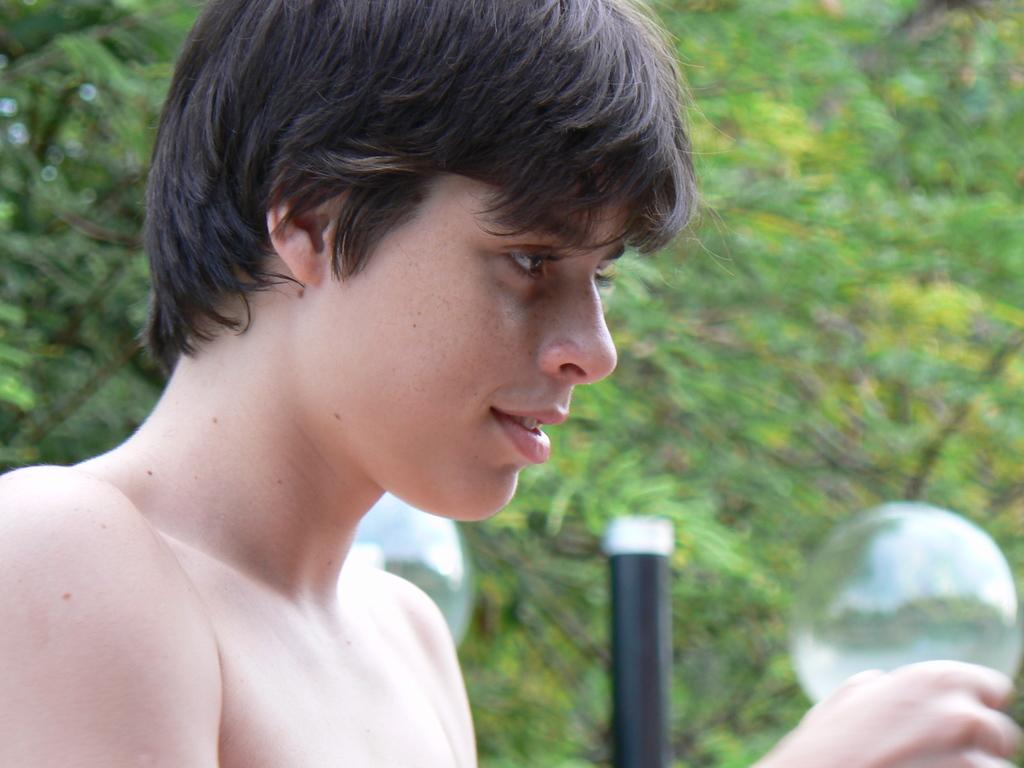Who or what is in the image? There is a person in the image. What else can be seen in the air besides the person? There are bubbles in the air. What can be seen in the background of the image? There is a rod and trees present in the background of the image. How many snakes are crawling on the person in the image? There are no snakes present in the image; the person is not interacting with any snakes. 